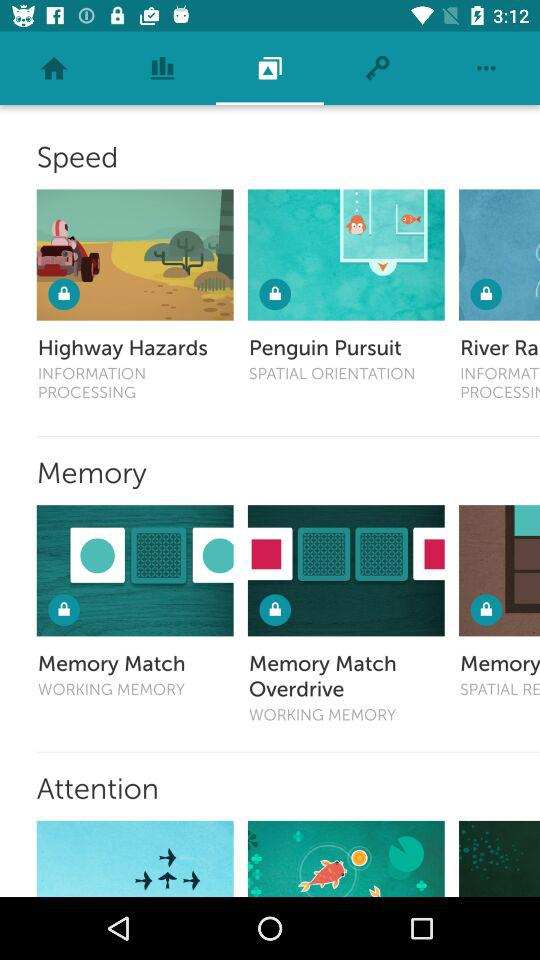How many games are there for the attention skill?
Answer the question using a single word or phrase. 3 